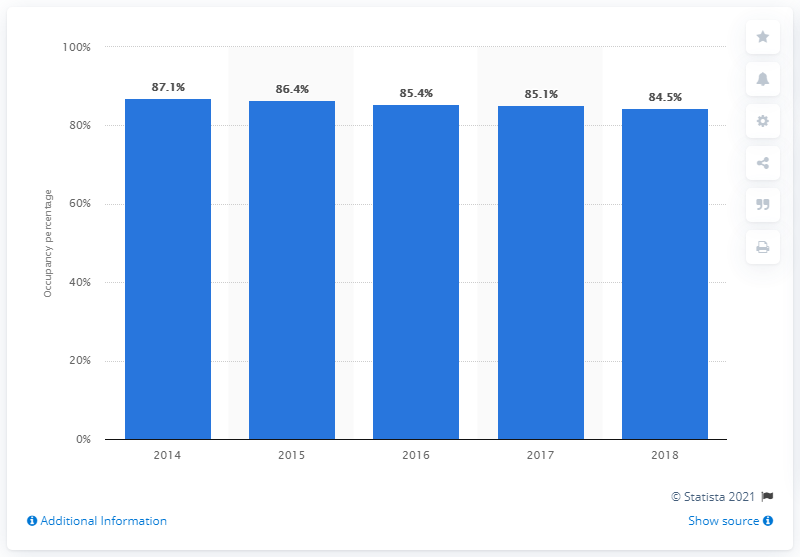Mention a couple of crucial points in this snapshot. In 2018, the occupancy rate for beds in skilled nursing facilities was 85.1%. In 2014, the occupancy percentage of beds in skilled nursing facilities was 87.1%. 